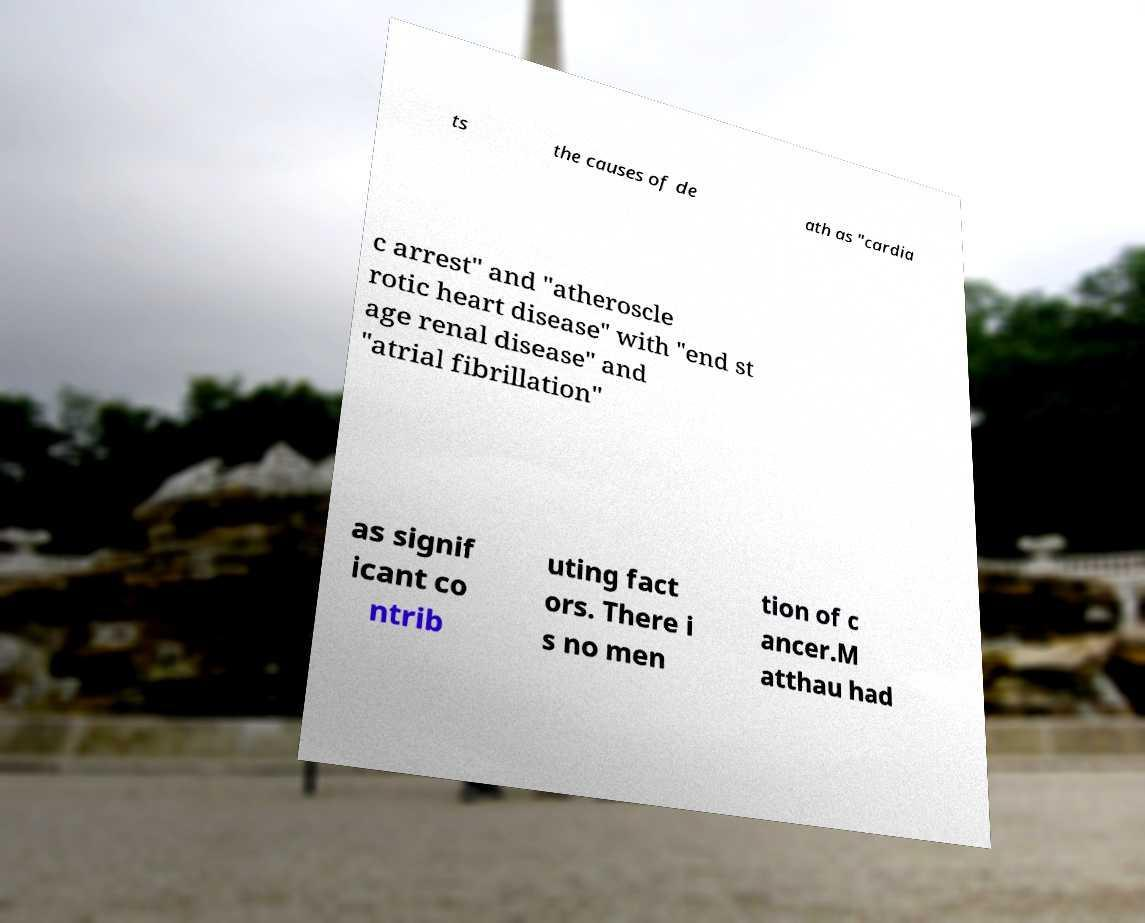There's text embedded in this image that I need extracted. Can you transcribe it verbatim? ts the causes of de ath as "cardia c arrest" and "atheroscle rotic heart disease" with "end st age renal disease" and "atrial fibrillation" as signif icant co ntrib uting fact ors. There i s no men tion of c ancer.M atthau had 